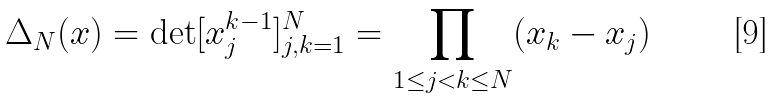<formula> <loc_0><loc_0><loc_500><loc_500>\Delta _ { N } ( x ) = \det [ x _ { j } ^ { k - 1 } ] _ { j , k = 1 } ^ { N } = \prod _ { 1 \leq j < k \leq N } ( x _ { k } - x _ { j } )</formula> 